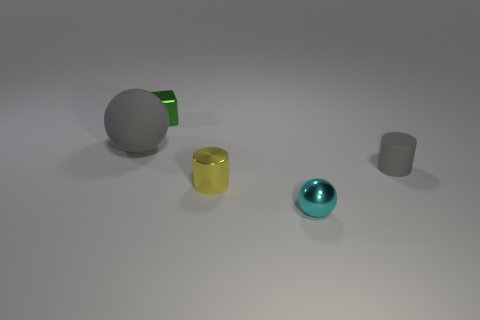What is the shape of the tiny shiny thing that is behind the small gray thing?
Your answer should be very brief. Cube. The big gray object that is the same material as the gray cylinder is what shape?
Offer a terse response. Sphere. What number of rubber things are either gray cylinders or big spheres?
Your response must be concise. 2. There is a gray thing that is on the left side of the gray object that is to the right of the small cyan metallic sphere; how many tiny green metal blocks are right of it?
Ensure brevity in your answer.  1. There is a matte thing that is behind the small gray cylinder; is it the same size as the rubber thing that is to the right of the small sphere?
Your answer should be compact. No. What material is the other thing that is the same shape as the large thing?
Ensure brevity in your answer.  Metal. How many tiny things are yellow cylinders or cylinders?
Provide a short and direct response. 2. What material is the gray ball?
Offer a very short reply. Rubber. The thing that is both in front of the green shiny cube and behind the tiny rubber object is made of what material?
Provide a succinct answer. Rubber. Does the matte sphere have the same color as the tiny cylinder right of the yellow thing?
Give a very brief answer. Yes. 